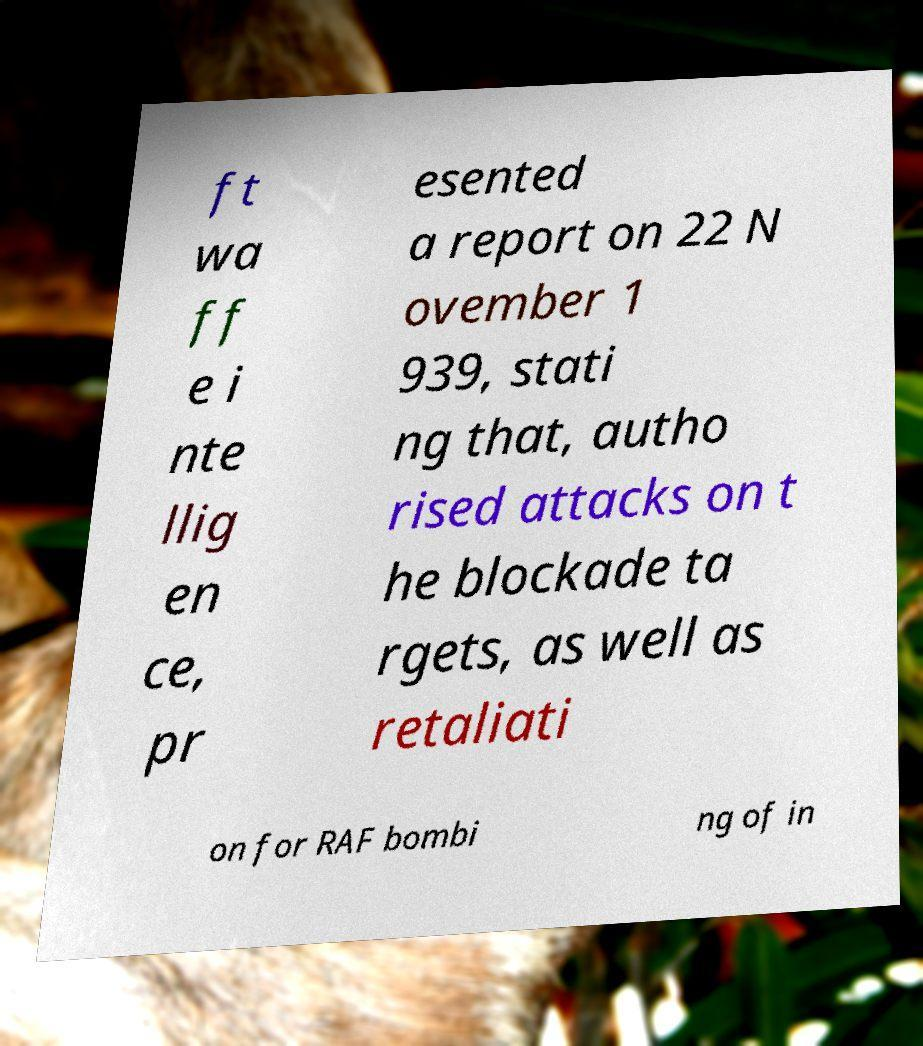Could you assist in decoding the text presented in this image and type it out clearly? ft wa ff e i nte llig en ce, pr esented a report on 22 N ovember 1 939, stati ng that, autho rised attacks on t he blockade ta rgets, as well as retaliati on for RAF bombi ng of in 